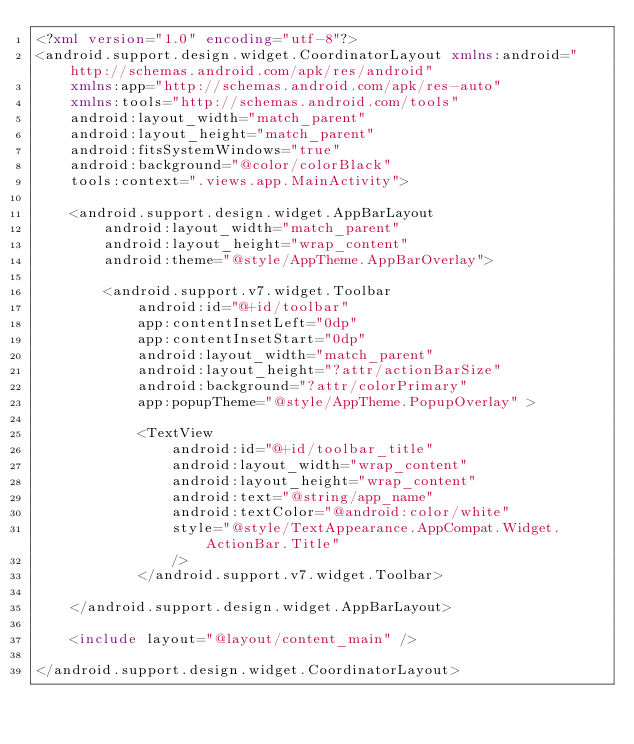<code> <loc_0><loc_0><loc_500><loc_500><_XML_><?xml version="1.0" encoding="utf-8"?>
<android.support.design.widget.CoordinatorLayout xmlns:android="http://schemas.android.com/apk/res/android"
    xmlns:app="http://schemas.android.com/apk/res-auto"
    xmlns:tools="http://schemas.android.com/tools"
    android:layout_width="match_parent"
    android:layout_height="match_parent"
    android:fitsSystemWindows="true"
    android:background="@color/colorBlack"
    tools:context=".views.app.MainActivity">

    <android.support.design.widget.AppBarLayout
        android:layout_width="match_parent"
        android:layout_height="wrap_content"
        android:theme="@style/AppTheme.AppBarOverlay">

        <android.support.v7.widget.Toolbar
            android:id="@+id/toolbar"
            app:contentInsetLeft="0dp"
            app:contentInsetStart="0dp"
            android:layout_width="match_parent"
            android:layout_height="?attr/actionBarSize"
            android:background="?attr/colorPrimary"
            app:popupTheme="@style/AppTheme.PopupOverlay" >

            <TextView
                android:id="@+id/toolbar_title"
                android:layout_width="wrap_content"
                android:layout_height="wrap_content"
                android:text="@string/app_name"
                android:textColor="@android:color/white"
                style="@style/TextAppearance.AppCompat.Widget.ActionBar.Title"
                />
            </android.support.v7.widget.Toolbar>

    </android.support.design.widget.AppBarLayout>

    <include layout="@layout/content_main" />

</android.support.design.widget.CoordinatorLayout>
</code> 